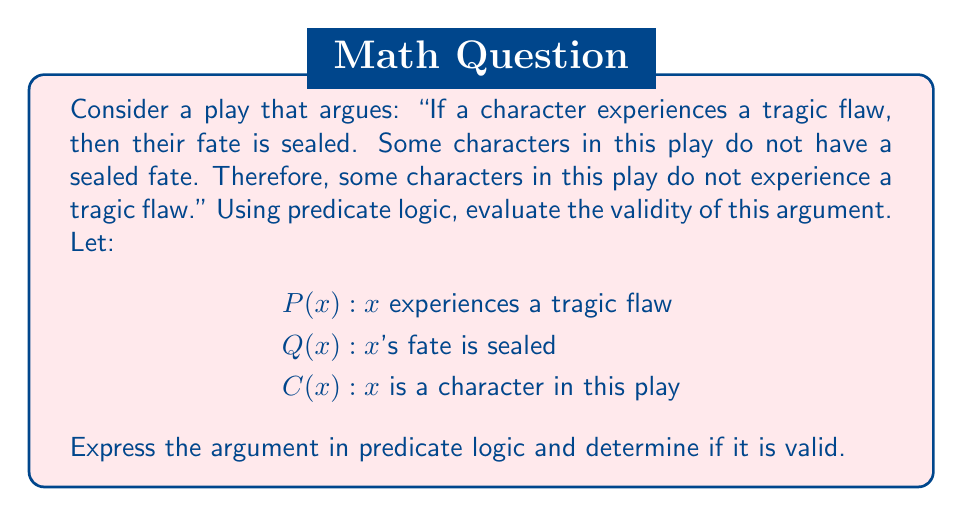Give your solution to this math problem. To evaluate this argument using predicate logic, we'll follow these steps:

1) Express the premises and conclusion in predicate logic:

   Premise 1: $\forall x (P(x) \rightarrow Q(x))$
   Premise 2: $\exists x (C(x) \wedge \neg Q(x))$
   Conclusion: $\exists x (C(x) \wedge \neg P(x))$

2) To prove validity, we need to show that if the premises are true, the conclusion must also be true. Let's assume the premises are true and see if we can derive the conclusion.

3) From Premise 2, we know that there exists some character whose fate is not sealed. Let's call this character 'a':

   $C(a) \wedge \neg Q(a)$

4) Now, let's consider Premise 1 for this specific character 'a':

   $P(a) \rightarrow Q(a)$

5) This is logically equivalent to:

   $\neg Q(a) \rightarrow \neg P(a)$

6) We know $\neg Q(a)$ is true from step 3, so we can conclude $\neg P(a)$

7) Combining this with $C(a)$ from step 3, we get:

   $C(a) \wedge \neg P(a)$

8) This matches the form of our conclusion: $\exists x (C(x) \wedge \neg P(x))$

Therefore, the conclusion follows logically from the premises, and the argument is valid.
Answer: The argument is valid. The conclusion $\exists x (C(x) \wedge \neg P(x))$ can be derived from the premises $\forall x (P(x) \rightarrow Q(x))$ and $\exists x (C(x) \wedge \neg Q(x))$ using predicate logic. 